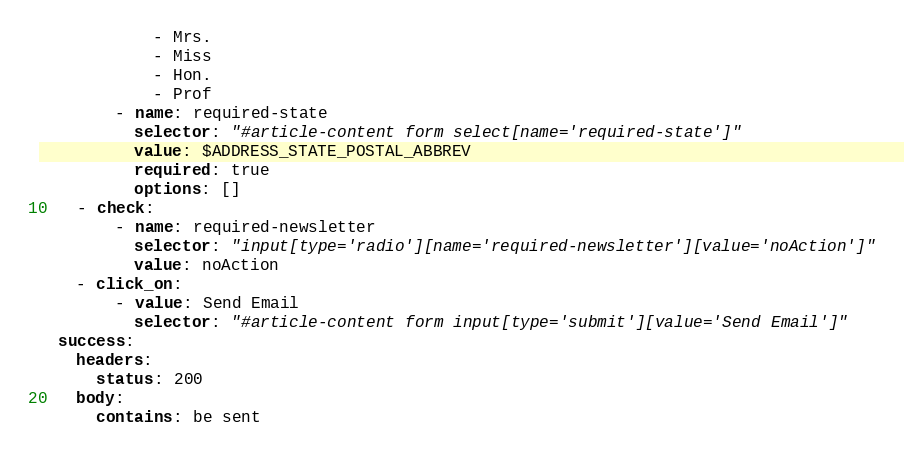Convert code to text. <code><loc_0><loc_0><loc_500><loc_500><_YAML_>            - Mrs.
            - Miss
            - Hon.
            - Prof
        - name: required-state
          selector: "#article-content form select[name='required-state']"
          value: $ADDRESS_STATE_POSTAL_ABBREV
          required: true
          options: []
    - check:
        - name: required-newsletter
          selector: "input[type='radio'][name='required-newsletter'][value='noAction']"
          value: noAction
    - click_on:
        - value: Send Email
          selector: "#article-content form input[type='submit'][value='Send Email']"
  success:
    headers:
      status: 200
    body:
      contains: be sent
      
</code> 